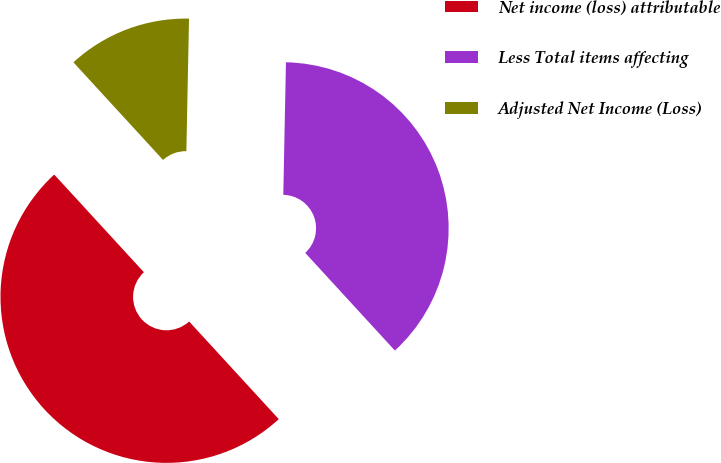<chart> <loc_0><loc_0><loc_500><loc_500><pie_chart><fcel>Net income (loss) attributable<fcel>Less Total items affecting<fcel>Adjusted Net Income (Loss)<nl><fcel>50.0%<fcel>37.86%<fcel>12.14%<nl></chart> 